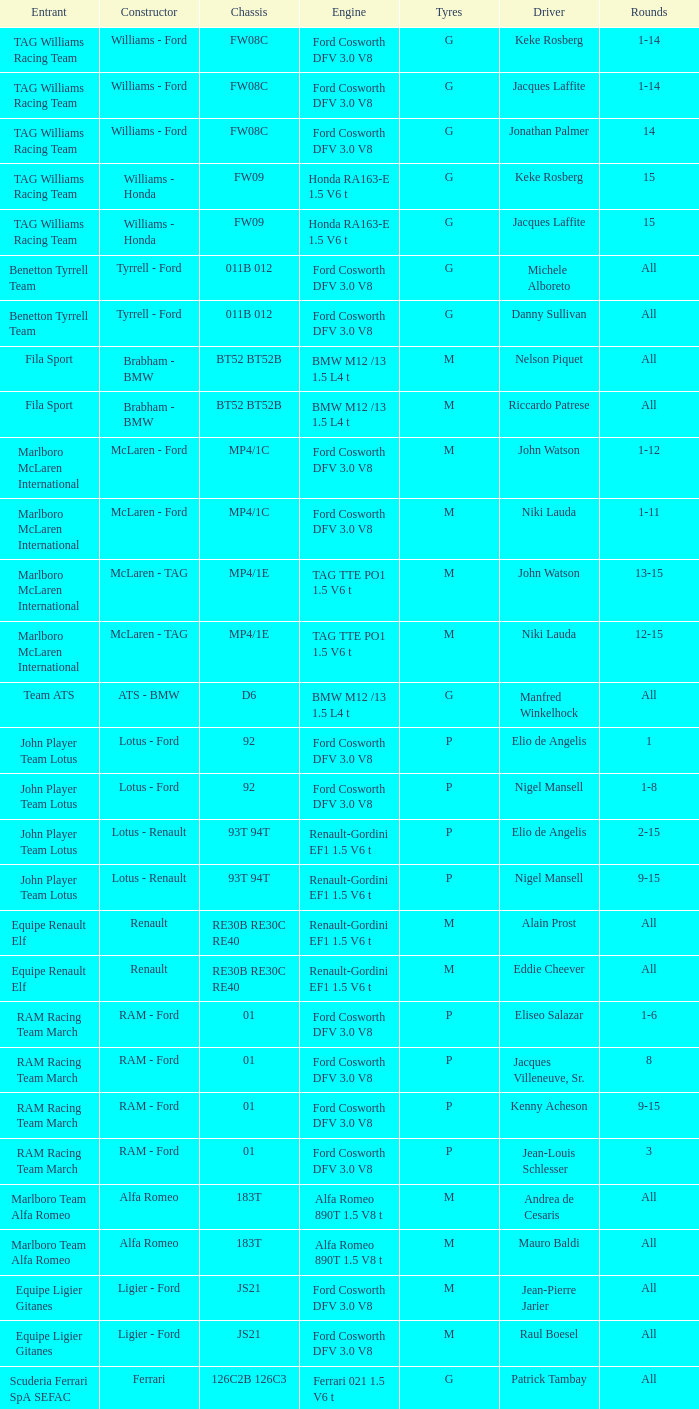Who is the Constructor for driver Piercarlo Ghinzani and a Ford cosworth dfv 3.0 v8 engine? Osella - Ford. 